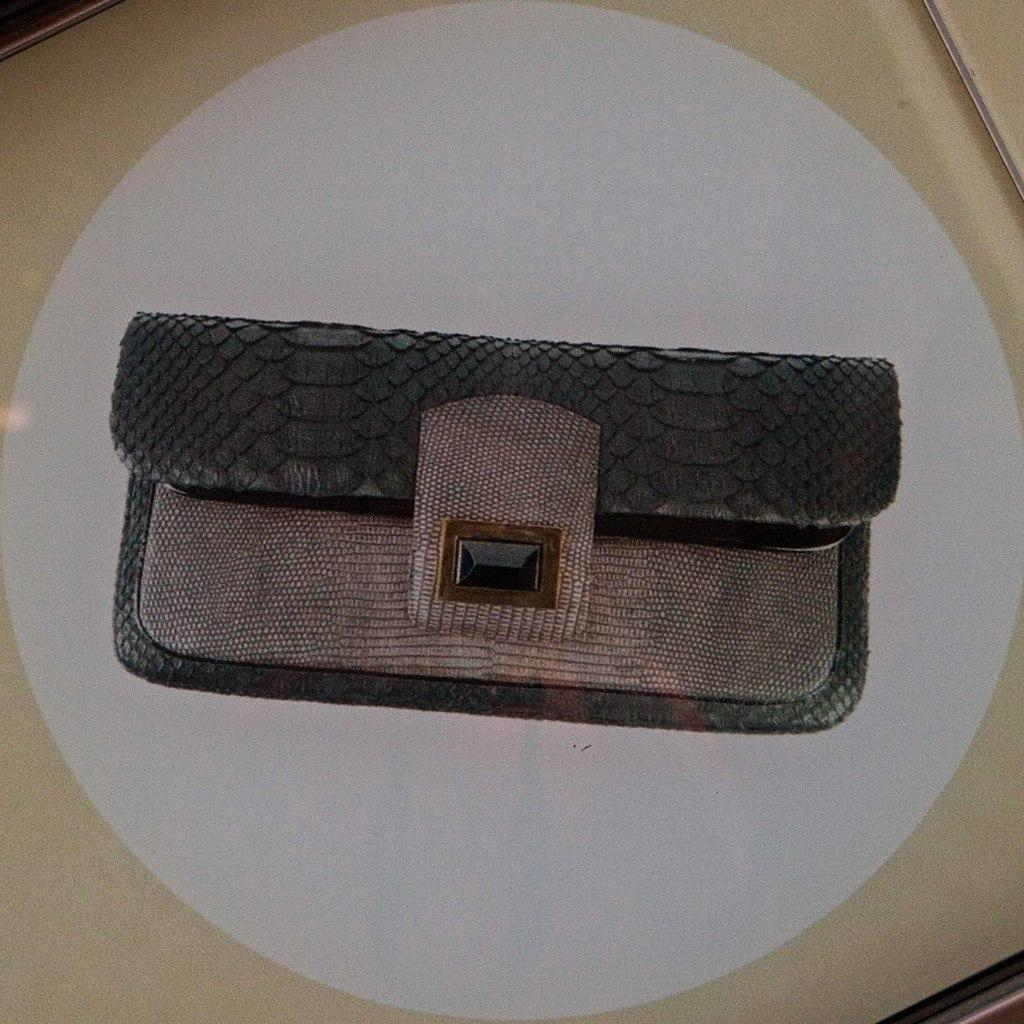What object is the main focus of the image? There is a woman's wallet in the image. Where is the wallet located in the image? The wallet is in the center of the image. On what surface is the wallet placed? The wallet is on a surface. How many stars can be seen in the wallet in the image? There are no stars visible in the wallet or the image. What is the name of the woman's son, who is not present in the image? The name of the woman's son cannot be determined from the image, as he is not present. 